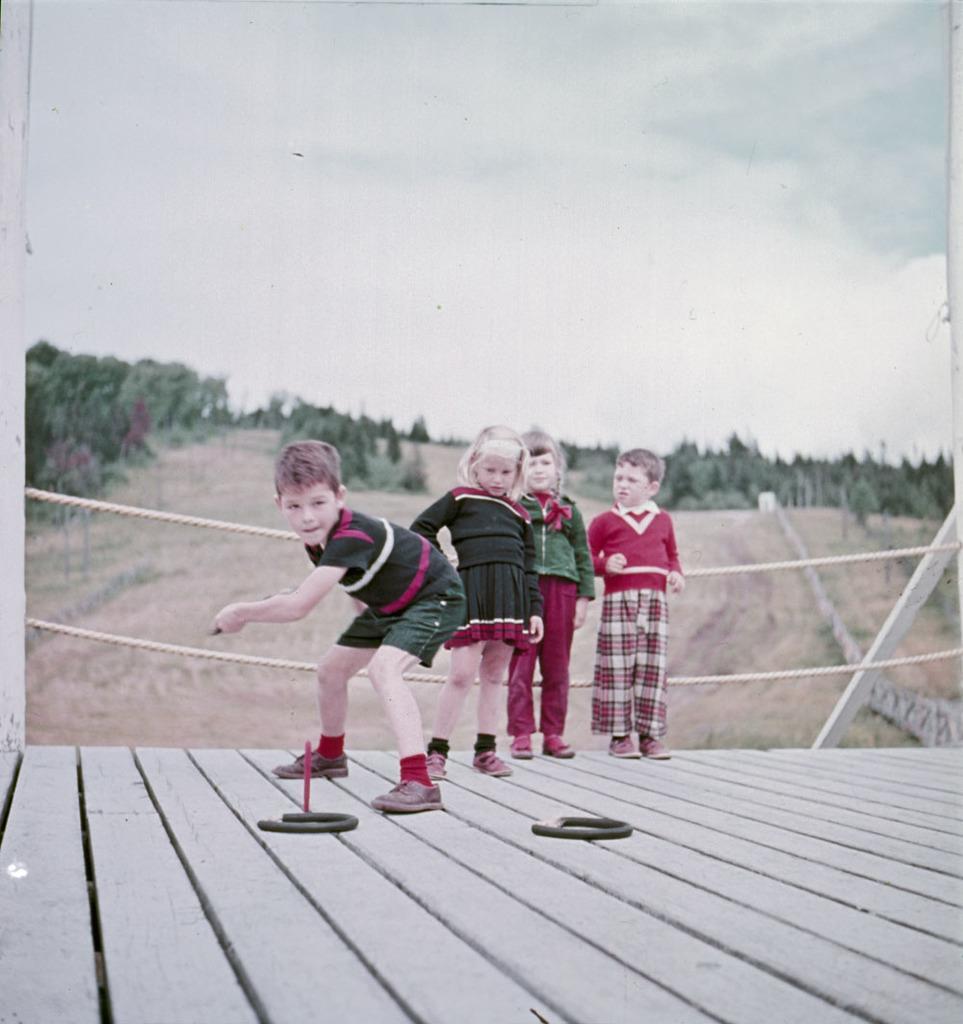How would you summarize this image in a sentence or two? In this image we can see some kids standing on the wooden bridge playing some game, there are some kids leaning to the fencing and at the background of the image there are some trees and cloudy sky. 